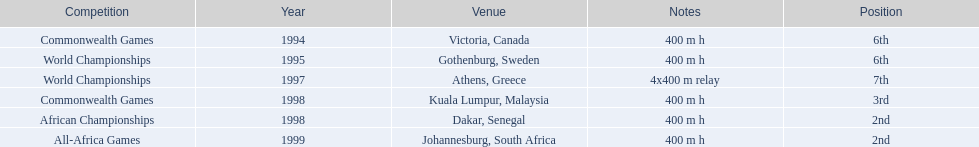What country was the 1997 championships held in? Athens, Greece. What long was the relay? 4x400 m relay. 